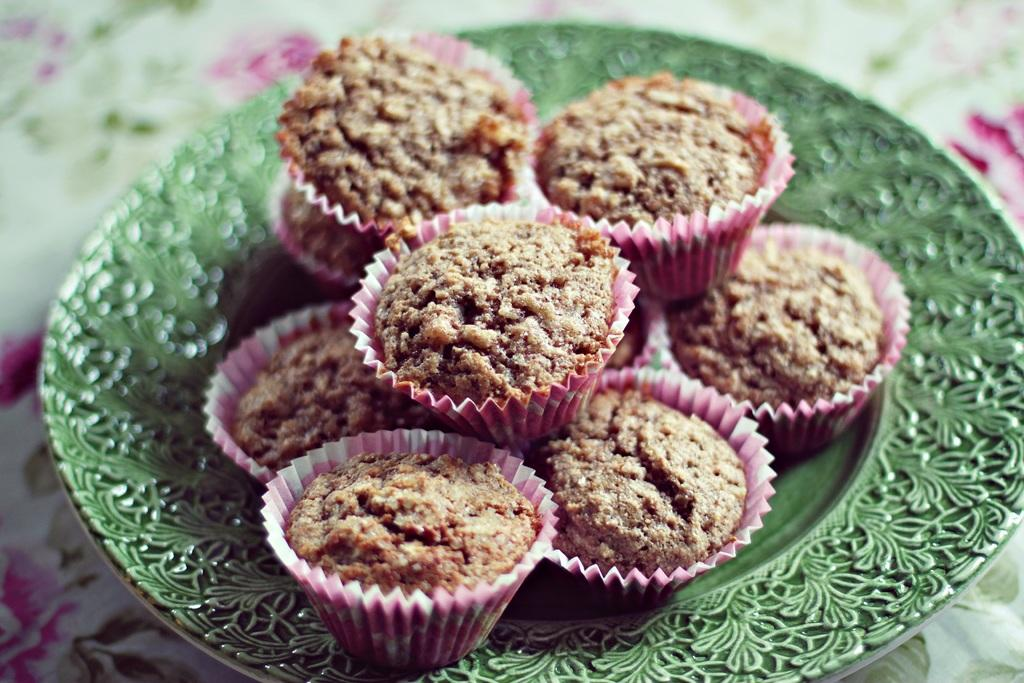What type of food is visible in the image? There is a group of cupcakes in the image. How are the cupcakes arranged in the image? The cupcakes are placed on a plate. Where is the plate with cupcakes located? The plate with cupcakes is kept on a surface. What is the moon doing in the image? The moon is not present in the image; it is a celestial body and not related to the cupcakes or the plate. 